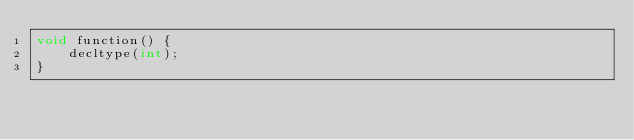<code> <loc_0><loc_0><loc_500><loc_500><_C++_>void function() {
    decltype(int);
}</code> 